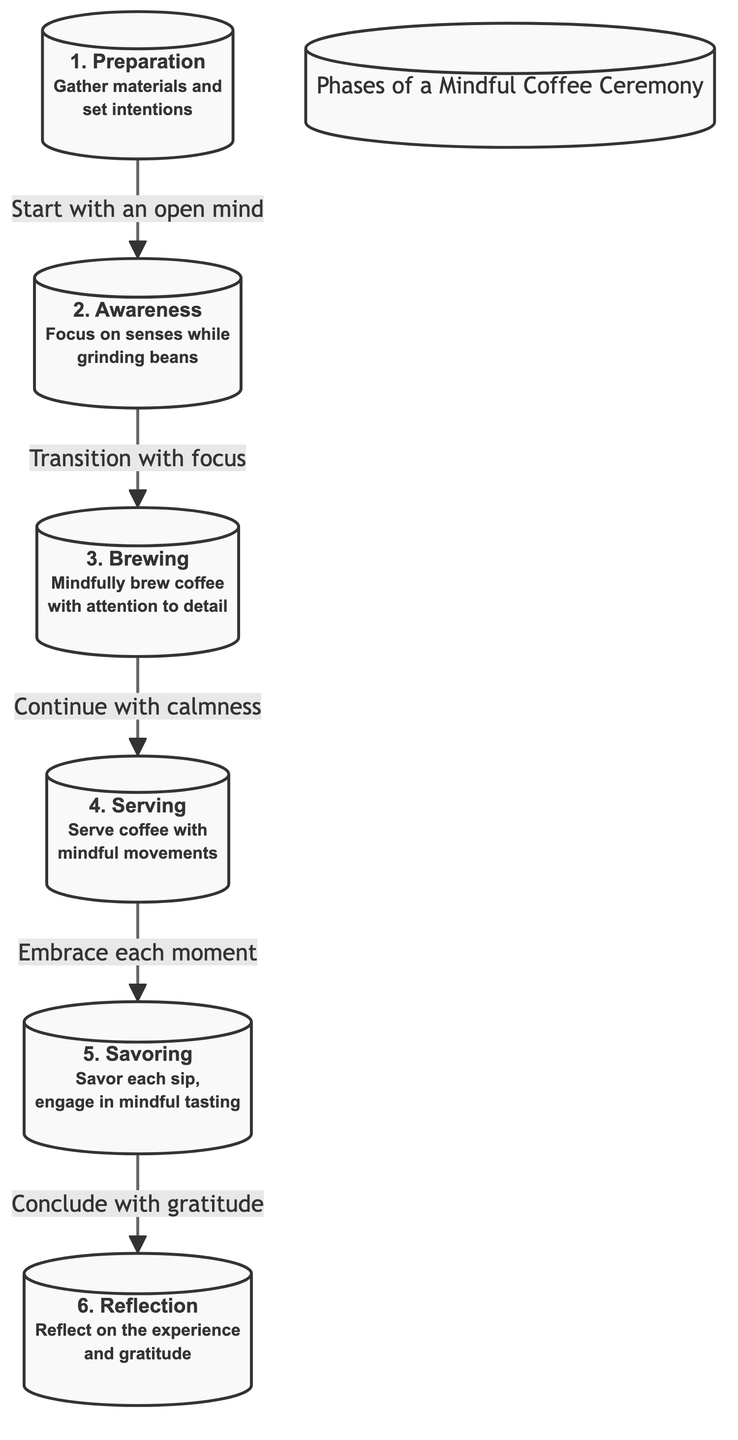What is the first phase of the mindful coffee ceremony? The diagram indicates that the first phase is "Preparation," which involves gathering materials and setting intentions.
Answer: Preparation How many phases are present in the diagram? The diagram outlines six distinct phases of the mindful coffee ceremony.
Answer: 6 What is the last phase in the sequence? The diagram shows that the last phase is "Reflection," emphasizing the importance of reflecting on the experience and gratitude.
Answer: Reflection What is the relationship between the second and third phases? The diagram states that the transition from the second phase ("Awareness") to the third phase ("Brewing") is guided by focusing on detail while brewing coffee.
Answer: Transition with focus What does the fifth phase encourage participants to do? The fifth phase, "Savoring," encourages participants to savor each sip and engage in mindful tasting.
Answer: Savor each sip What phrase connects the fourth and fifth phases? The diagram specifies that the phrase connecting the fourth phase ("Serving") to the fifth phase ("Savoring") is "Embrace each moment."
Answer: Embrace each moment During which phase do participants grind coffee beans mindfully? The diagram identifies the second phase, "Awareness," as the stage where participants focus on their senses while grinding beans.
Answer: Awareness What is required to move from brewing to serving? The diagram indicates that the transition from the third phase ("Brewing") to the fourth phase ("Serving") requires calmness.
Answer: Continue with calmness What should participants do in the reflection phase? In the last phase, "Reflection," participants are encouraged to reflect on the experience and express gratitude.
Answer: Reflect on the experience and gratitude 